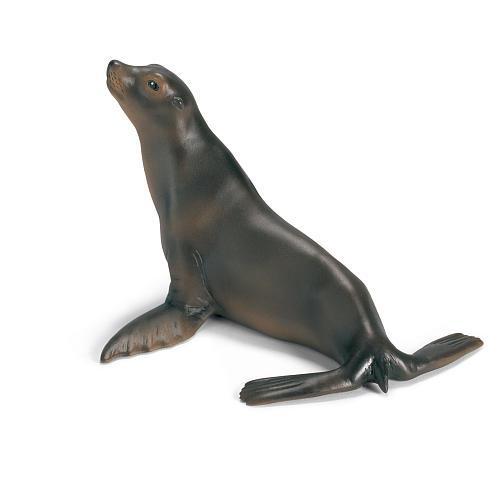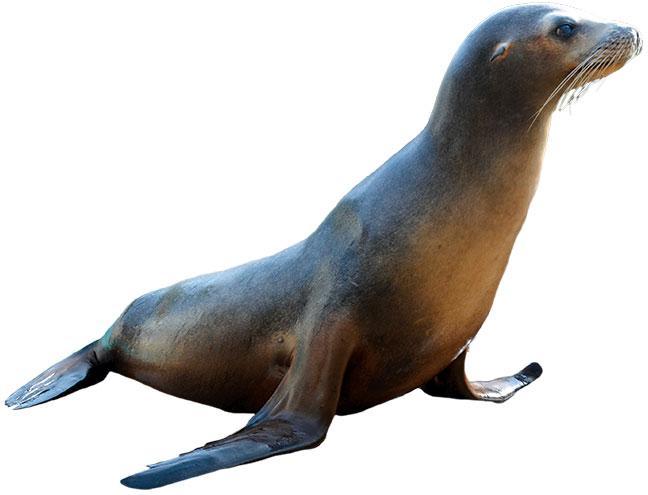The first image is the image on the left, the second image is the image on the right. Assess this claim about the two images: "There are only two seals and both are looking in different directions.". Correct or not? Answer yes or no. Yes. 